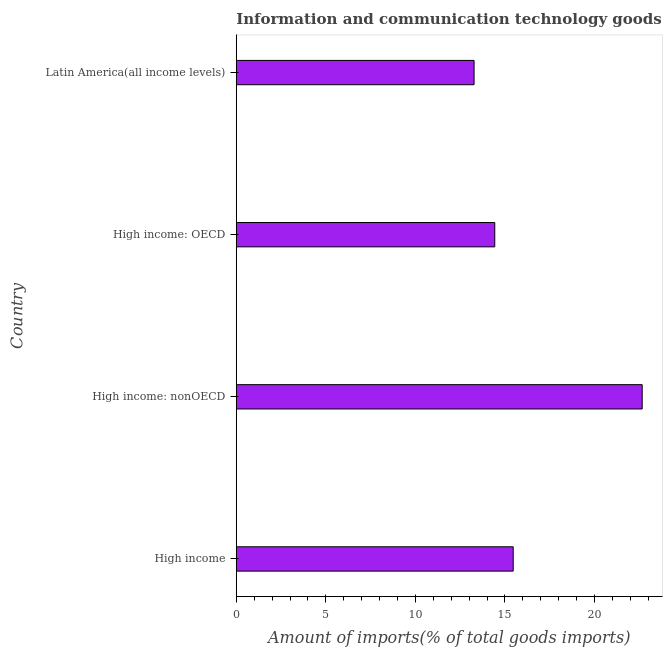What is the title of the graph?
Provide a succinct answer. Information and communication technology goods imported by different countries. What is the label or title of the X-axis?
Offer a terse response. Amount of imports(% of total goods imports). What is the amount of ict goods imports in High income: nonOECD?
Make the answer very short. 22.66. Across all countries, what is the maximum amount of ict goods imports?
Your answer should be compact. 22.66. Across all countries, what is the minimum amount of ict goods imports?
Give a very brief answer. 13.27. In which country was the amount of ict goods imports maximum?
Keep it short and to the point. High income: nonOECD. In which country was the amount of ict goods imports minimum?
Offer a terse response. Latin America(all income levels). What is the sum of the amount of ict goods imports?
Offer a terse response. 65.82. What is the difference between the amount of ict goods imports in High income: OECD and High income: nonOECD?
Keep it short and to the point. -8.23. What is the average amount of ict goods imports per country?
Offer a very short reply. 16.45. What is the median amount of ict goods imports?
Your answer should be very brief. 14.94. What is the ratio of the amount of ict goods imports in High income to that in High income: OECD?
Keep it short and to the point. 1.07. Is the difference between the amount of ict goods imports in High income and Latin America(all income levels) greater than the difference between any two countries?
Your response must be concise. No. Is the sum of the amount of ict goods imports in High income and High income: nonOECD greater than the maximum amount of ict goods imports across all countries?
Ensure brevity in your answer.  Yes. What is the difference between the highest and the lowest amount of ict goods imports?
Give a very brief answer. 9.38. Are all the bars in the graph horizontal?
Provide a short and direct response. Yes. How many countries are there in the graph?
Your answer should be very brief. 4. What is the difference between two consecutive major ticks on the X-axis?
Provide a succinct answer. 5. Are the values on the major ticks of X-axis written in scientific E-notation?
Give a very brief answer. No. What is the Amount of imports(% of total goods imports) of High income?
Your answer should be very brief. 15.46. What is the Amount of imports(% of total goods imports) in High income: nonOECD?
Ensure brevity in your answer.  22.66. What is the Amount of imports(% of total goods imports) in High income: OECD?
Your answer should be very brief. 14.43. What is the Amount of imports(% of total goods imports) of Latin America(all income levels)?
Your response must be concise. 13.27. What is the difference between the Amount of imports(% of total goods imports) in High income and High income: nonOECD?
Ensure brevity in your answer.  -7.2. What is the difference between the Amount of imports(% of total goods imports) in High income and High income: OECD?
Ensure brevity in your answer.  1.03. What is the difference between the Amount of imports(% of total goods imports) in High income and Latin America(all income levels)?
Offer a very short reply. 2.18. What is the difference between the Amount of imports(% of total goods imports) in High income: nonOECD and High income: OECD?
Ensure brevity in your answer.  8.23. What is the difference between the Amount of imports(% of total goods imports) in High income: nonOECD and Latin America(all income levels)?
Ensure brevity in your answer.  9.38. What is the difference between the Amount of imports(% of total goods imports) in High income: OECD and Latin America(all income levels)?
Offer a very short reply. 1.15. What is the ratio of the Amount of imports(% of total goods imports) in High income to that in High income: nonOECD?
Ensure brevity in your answer.  0.68. What is the ratio of the Amount of imports(% of total goods imports) in High income to that in High income: OECD?
Your answer should be compact. 1.07. What is the ratio of the Amount of imports(% of total goods imports) in High income to that in Latin America(all income levels)?
Give a very brief answer. 1.16. What is the ratio of the Amount of imports(% of total goods imports) in High income: nonOECD to that in High income: OECD?
Your answer should be compact. 1.57. What is the ratio of the Amount of imports(% of total goods imports) in High income: nonOECD to that in Latin America(all income levels)?
Give a very brief answer. 1.71. What is the ratio of the Amount of imports(% of total goods imports) in High income: OECD to that in Latin America(all income levels)?
Ensure brevity in your answer.  1.09. 